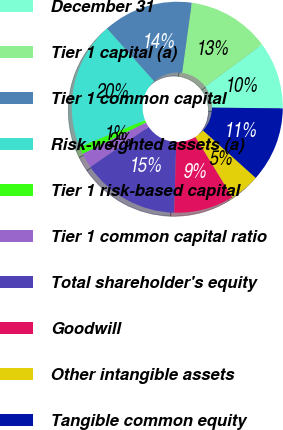<chart> <loc_0><loc_0><loc_500><loc_500><pie_chart><fcel>December 31<fcel>Tier 1 capital (a)<fcel>Tier 1 common capital<fcel>Risk-weighted assets (a)<fcel>Tier 1 risk-based capital<fcel>Tier 1 common capital ratio<fcel>Total shareholder's equity<fcel>Goodwill<fcel>Other intangible assets<fcel>Tangible common equity<nl><fcel>10.34%<fcel>12.64%<fcel>13.79%<fcel>19.54%<fcel>1.15%<fcel>2.3%<fcel>14.94%<fcel>9.2%<fcel>4.6%<fcel>11.49%<nl></chart> 